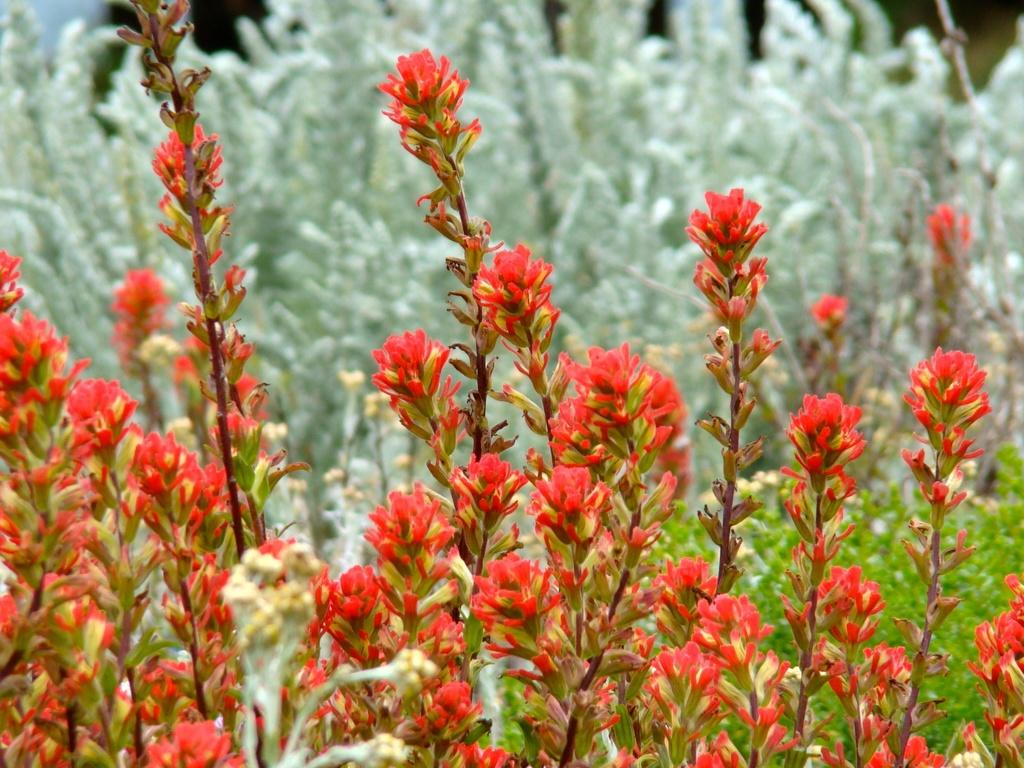What type of living organisms can be seen in the image? Plants can be seen in the image. What colors are present among the plants in the image? Some of the plants are red in color, and there are also white-colored plants visible in the image. Can you see a mountain in the background of the image? There is no mountain visible in the image; it only features plants. 